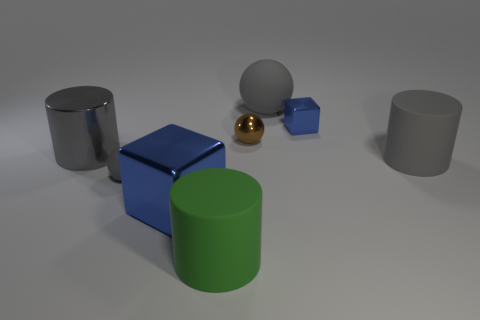Do the big rubber sphere and the sphere that is left of the big green object have the same color?
Your answer should be compact. Yes. Is the material of the green object the same as the large gray object to the left of the big ball?
Provide a short and direct response. No. The tiny sphere that is behind the sphere in front of the small brown ball is made of what material?
Keep it short and to the point. Metal. Are there more rubber spheres that are behind the metal cylinder than green metal objects?
Offer a very short reply. Yes. Are any small gray matte objects visible?
Offer a very short reply. Yes. What color is the rubber sphere in front of the metal cylinder?
Offer a terse response. Gray. There is another ball that is the same size as the brown metallic sphere; what is its material?
Make the answer very short. Rubber. What number of other things are there of the same material as the green object
Offer a terse response. 3. There is a ball that is on the right side of the big shiny cube and in front of the tiny metal block; what color is it?
Your answer should be very brief. Brown. What number of things are either gray rubber balls that are left of the tiny brown thing or large shiny things?
Your response must be concise. 3. 